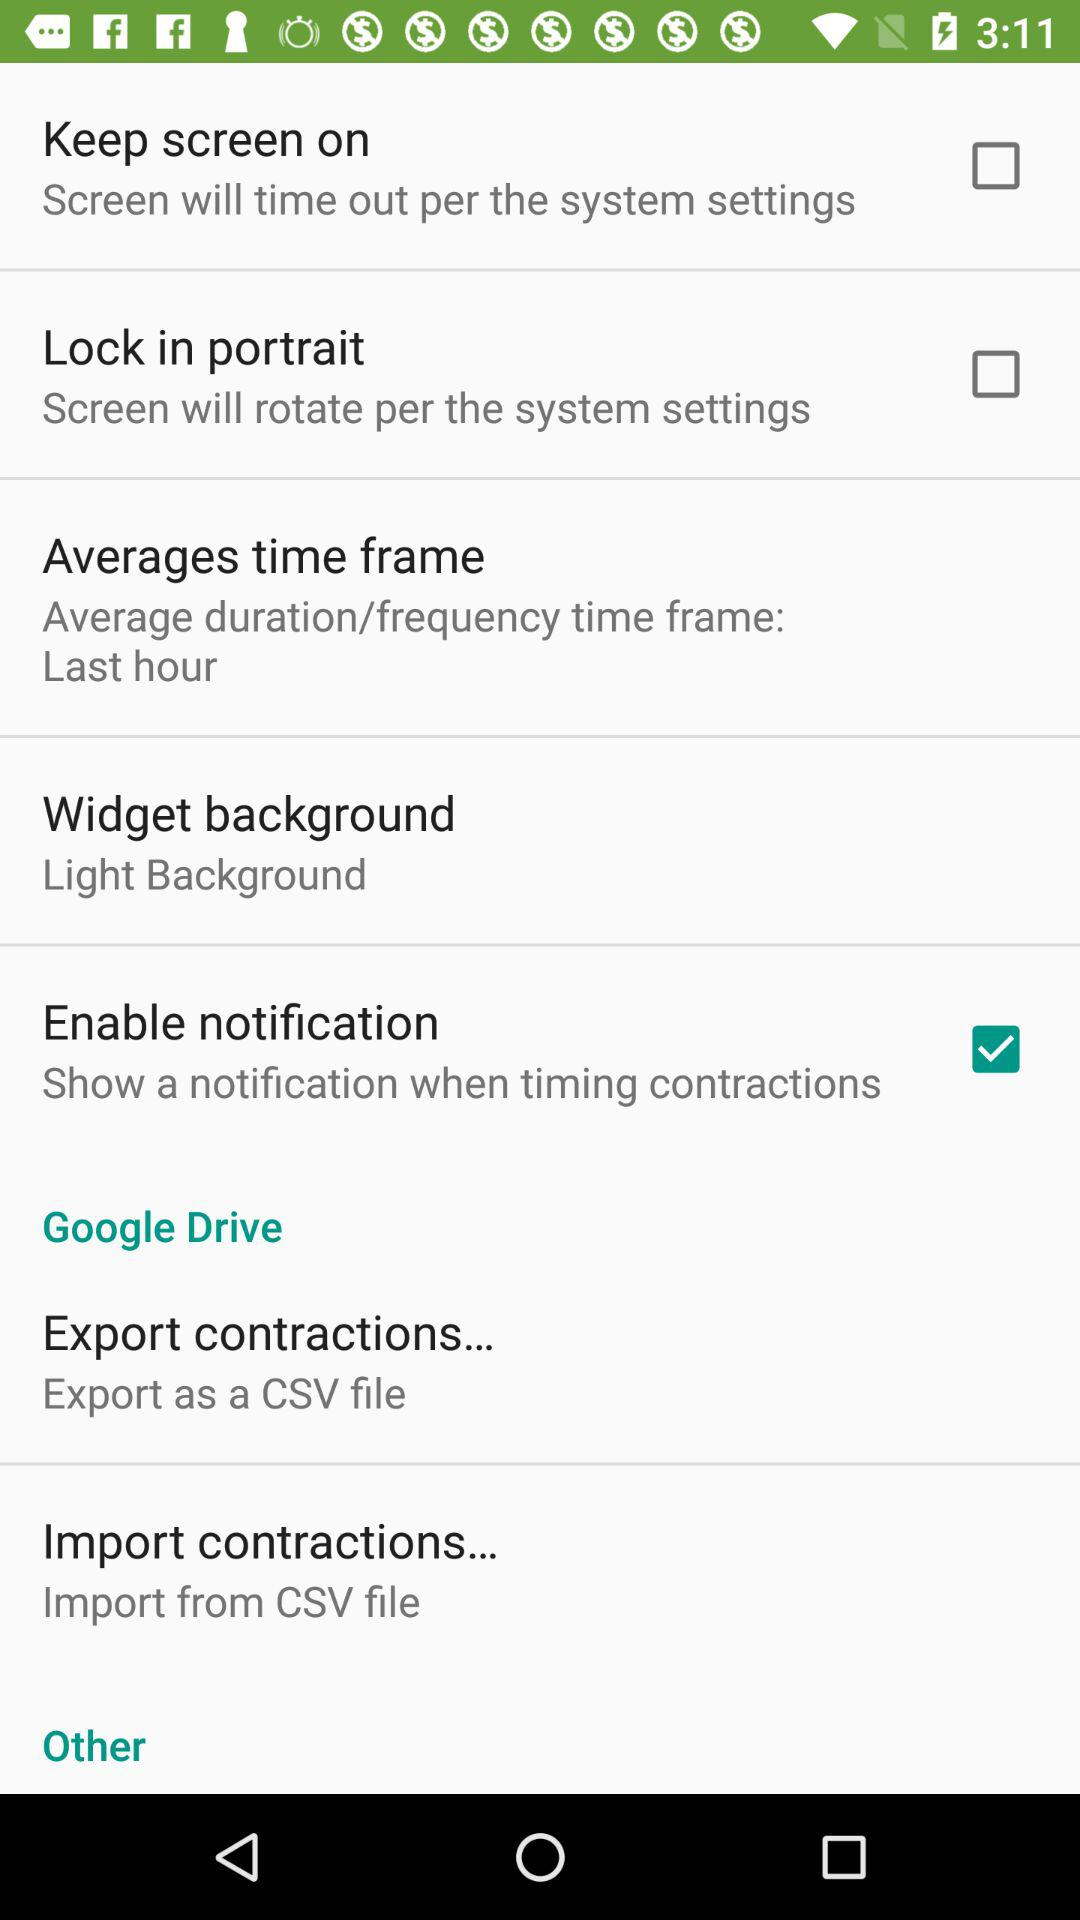What is the status of the "Enable notification"? The status is "on". 